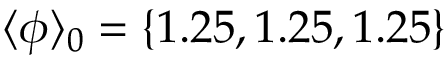<formula> <loc_0><loc_0><loc_500><loc_500>\langle \phi \rangle _ { 0 } = \{ 1 . 2 5 , 1 . 2 5 , 1 . 2 5 \}</formula> 